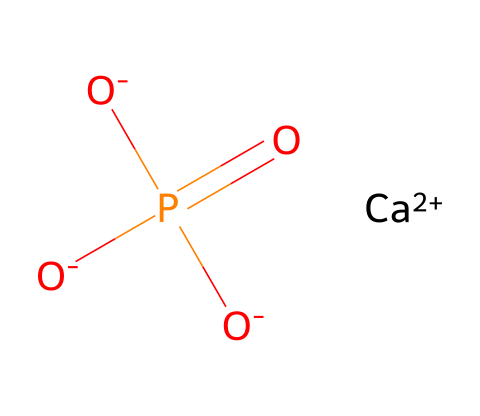What is the name of this chemical? The chemical represented by the SMILES is calcium phosphate, which is a compound formed from calcium ions and phosphate groups.
Answer: calcium phosphate How many oxygen atoms are present in this structure? By analyzing the SMILES, there are four oxygen atoms indicated. The phosphate group has three oxygen atoms, and there is one additional oxygen atom in the ionic form.
Answer: four What is the oxidation state of calcium in this compound? Calcium is represented as [Ca++] in the SMILES notation, indicating that it has a +2 oxidation state.
Answer: +2 How many phosphorus atoms are in the structure? The SMILES shows a single phosphorus atom in the phosphate group. Therefore, there is one phosphorus atom present in the structure.
Answer: one What type of ions are involved in this compound? The structure contains calcium ions (Ca++) and phosphate ions (PO4^3-) in its formation. The Ca++ indicates a cation, and the phosphate contains a negative charge.
Answer: cations and anions What kind of bonding is primarily present in this compound? The structure involves ionic bonding, as the calcium ions carry a positive charge and the phosphate group has a negative charge, attracting each other.
Answer: ionic 